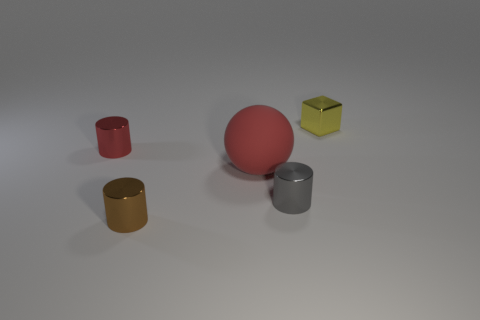Subtract all tiny brown metallic cylinders. How many cylinders are left? 2 Add 1 large objects. How many objects exist? 6 Subtract all cylinders. How many objects are left? 2 Subtract all brown cylinders. How many cylinders are left? 2 Subtract 1 spheres. How many spheres are left? 0 Subtract all red cylinders. Subtract all yellow cubes. How many cylinders are left? 2 Subtract all brown cylinders. How many brown balls are left? 0 Subtract all tiny green matte blocks. Subtract all tiny objects. How many objects are left? 1 Add 3 large things. How many large things are left? 4 Add 5 shiny objects. How many shiny objects exist? 9 